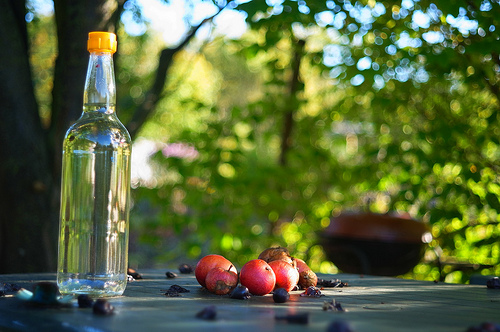Is there anything in the image that suggests a human presence? The arranged bottle and apples suggest human organization, and the location on what seems to be a patio table implies that someone may be nearby or this setting was recently inhabited. 